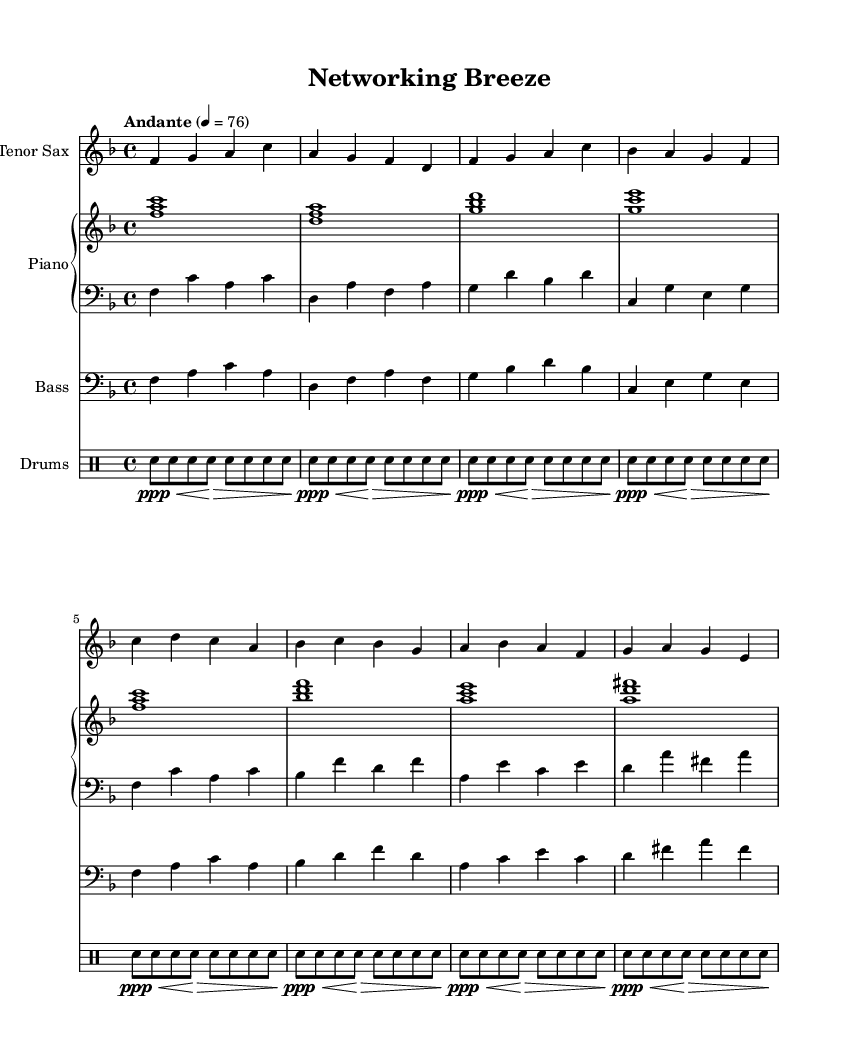What is the key signature of this music? The key signature is F major, which has one flat (B flat).
Answer: F major What is the time signature of this piece? The time signature is 4/4, indicating four beats per measure.
Answer: 4/4 What is the tempo marking for the music? The tempo marking is "Andante", which suggests a moderate pace.
Answer: Andante How many measures are there in the saxophone melody? The saxophone melody consists of 8 measures as seen in the notation.
Answer: 8 What is the dynamic level indicated for the drums part? The dynamic level indicated for the drums part is ppp, which stands for pianississimo (very very soft).
Answer: ppp Which instrument plays the melody in this arrangement? The melody is played by the Tenor Saxophone as specified in the score.
Answer: Tenor Sax What type of music does this piece represent? This piece represents Soft Jazz, characterized by its smooth and relaxing ambiance.
Answer: Soft Jazz 